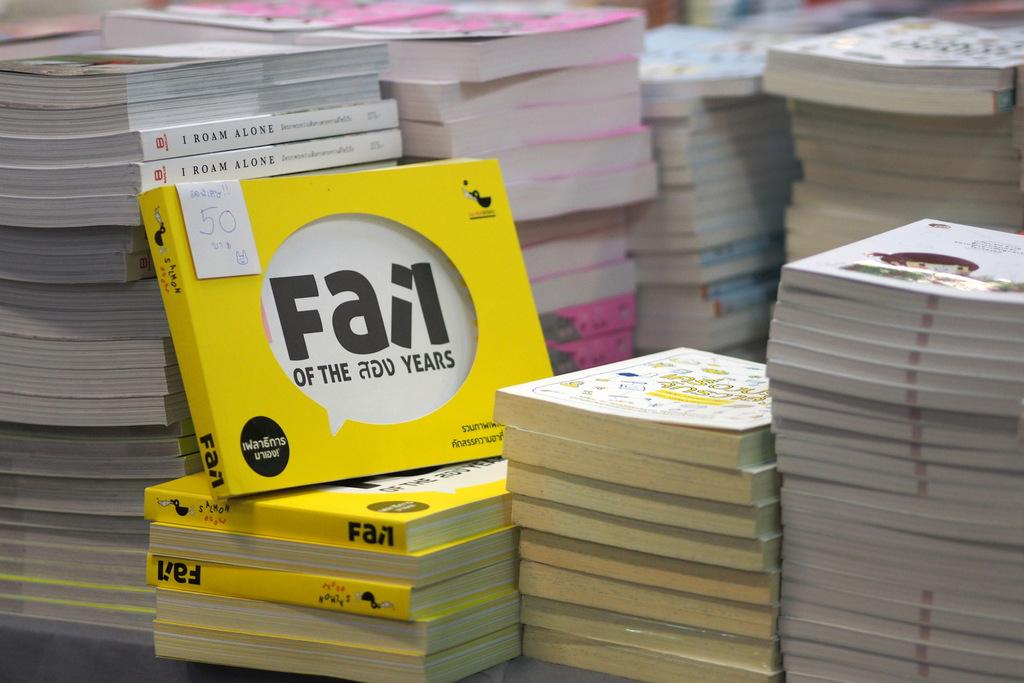<image>
Summarize the visual content of the image. A number of books called Fail of the Add years stacked together. 